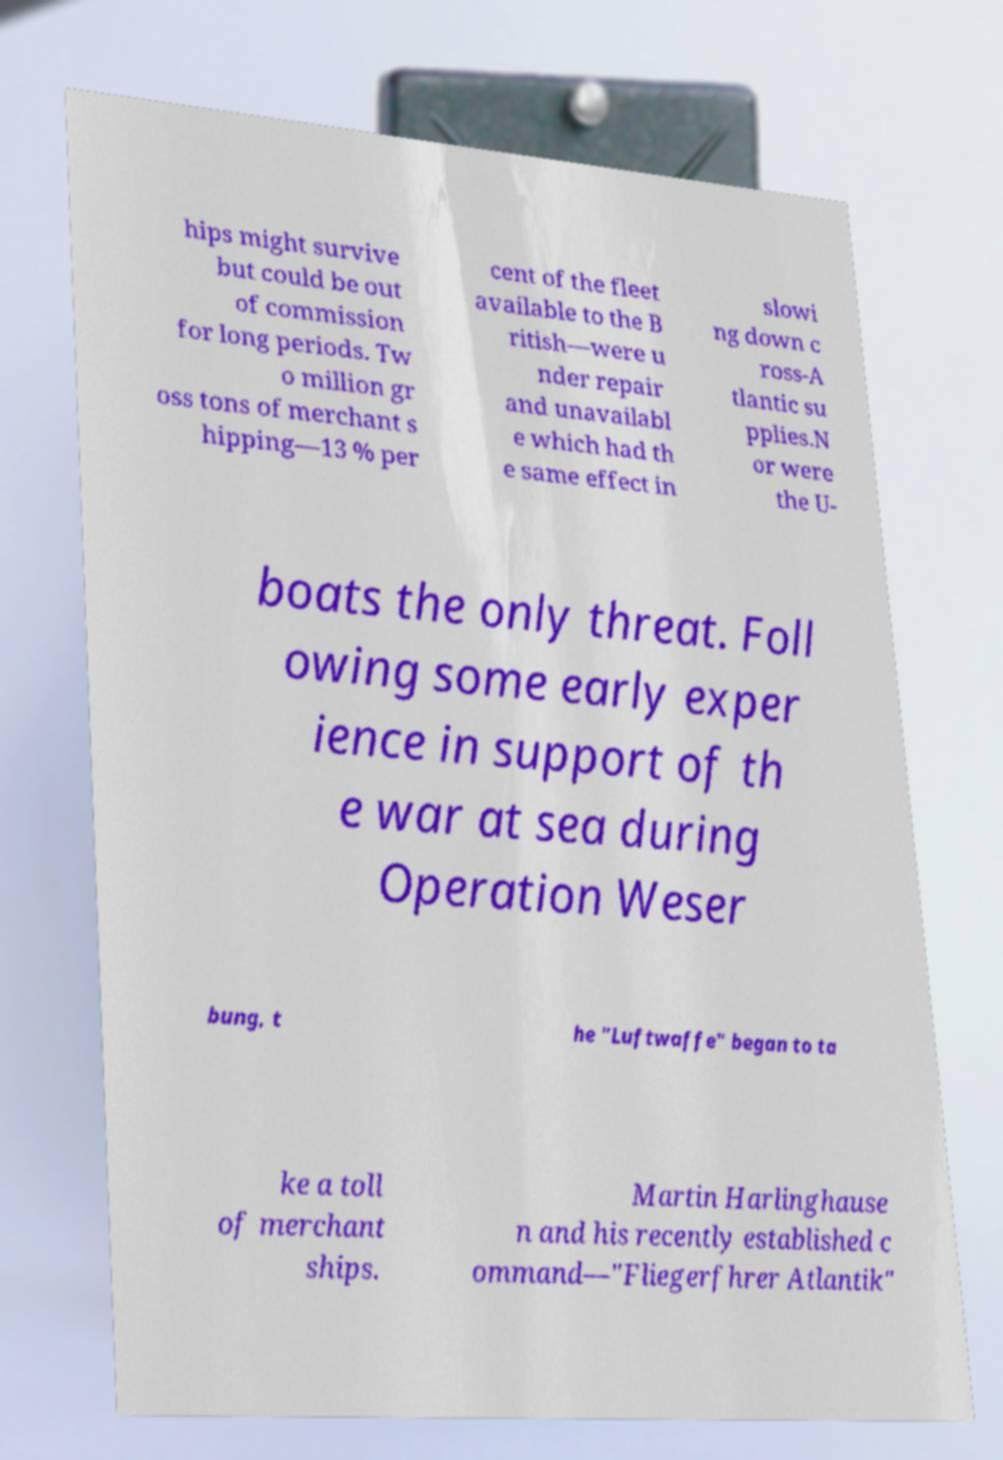Can you accurately transcribe the text from the provided image for me? hips might survive but could be out of commission for long periods. Tw o million gr oss tons of merchant s hipping—13 % per cent of the fleet available to the B ritish—were u nder repair and unavailabl e which had th e same effect in slowi ng down c ross-A tlantic su pplies.N or were the U- boats the only threat. Foll owing some early exper ience in support of th e war at sea during Operation Weser bung, t he "Luftwaffe" began to ta ke a toll of merchant ships. Martin Harlinghause n and his recently established c ommand—"Fliegerfhrer Atlantik" 